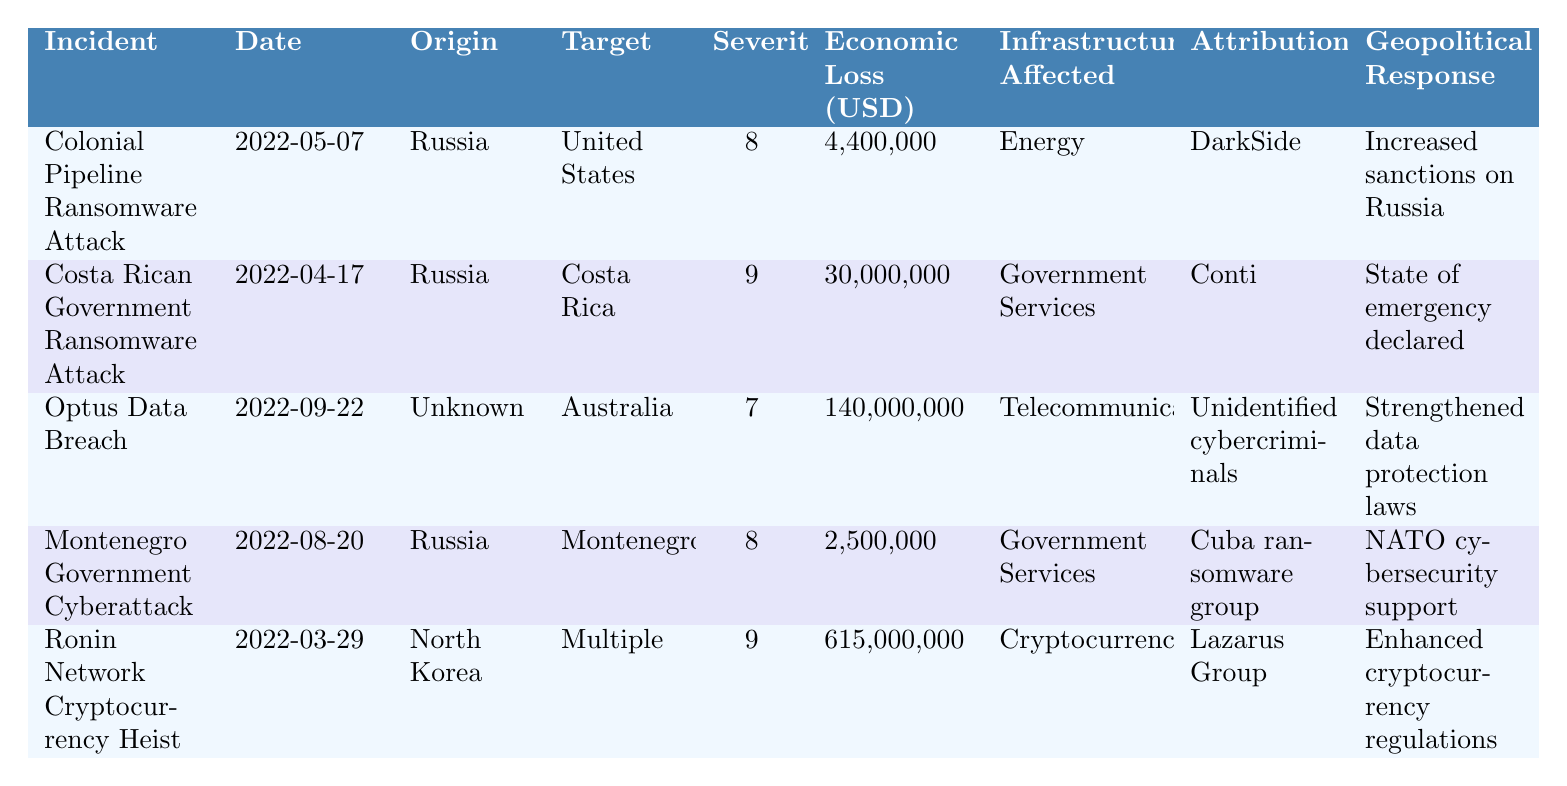What was the total economic loss in USD due to the incidents listed? To find the total economic loss, sum the economic losses of all incidents from the table: 4,400,000 + 30,000,000 + 140,000,000 + 2,500,000 + 615,000,000 = 792,900,000.
Answer: 792,900,000 Which incident had the highest impact severity? The impact severity values are 8, 9, 7, 8, and 9. The highest value is 9, which corresponds to the "Costa Rican Government Ransomware Attack" and the "Ronin Network Cryptocurrency Heist."
Answer: Costa Rican Government Ransomware Attack and Ronin Network Cryptocurrency Heist How many incidents originated from Russia? The table lists three incidents with Russia as the country of origin: "Colonial Pipeline Ransomware Attack," "Costa Rican Government Ransomware Attack," and "Montenegro Government Cyberattack."
Answer: 3 Which incident affected critical infrastructure related to cryptocurrency? The only incident affecting cryptocurrency, as identified in the table, is the "Ronin Network Cryptocurrency Heist."
Answer: Ronin Network Cryptocurrency Heist Are there any incidents that resulted in a state of emergency declared? Yes, the "Costa Rican Government Ransomware Attack" had a geopolitical response of a state of emergency declared.
Answer: Yes What is the average economic loss for incidents attributed to Russian cybercriminals? The economic losses for incidents attributed to Russia are: 4,400,000 (Colonial) + 30,000,000 (Costa Rican) + 2,500,000 (Montenegro) = 36,900,000. The average is 36,900,000 / 3 = 12,300,000.
Answer: 12,300,000 How did the diplomatic tension levels vary across the incidents? The diplomatic tension levels are "High" (2 incidents: Colonial Pipeline, Montenegro), "Medium" (2 incidents: Costa Rica, Ronin Network), and "Low" (1 incident: Optus). The tensions were split into high, medium, and low.
Answer: Split into high, medium, and low tensions What response measures were taken for incidents attributed to North Korea? The only incident attributable to North Korea is the "Ronin Network Cryptocurrency Heist," which resulted in enhanced cryptocurrency regulations.
Answer: Enhanced cryptocurrency regulations Which tech companies were involved in the Costa Rican Government Ransomware Attack? The table lists "Cisco" and "Fortinet" as the tech companies involved in the Costa Rican Government Ransomware Attack.
Answer: Cisco and Fortinet Did any incident result in a lower impact severity than the Optus Data Breach? The impact severity of the Optus Data Breach is 7. The incidents with lower severity are the "Montenegro Government Cyberattack" (8) and "Colonial Pipeline Ransomware Attack" (8). There are none with lower severity than 7.
Answer: No 